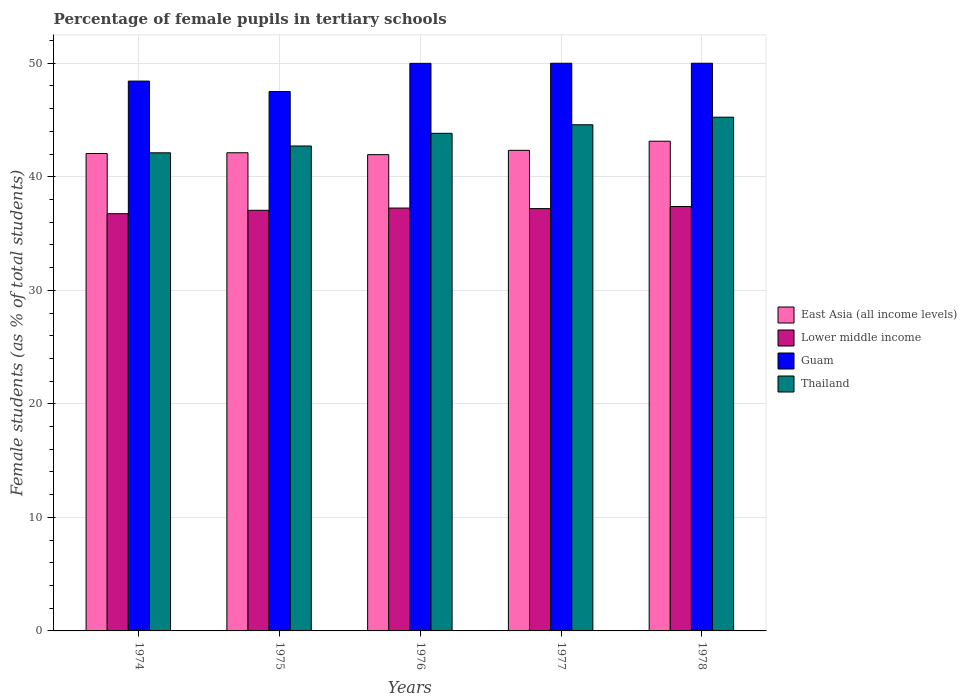How many different coloured bars are there?
Offer a terse response. 4. What is the label of the 2nd group of bars from the left?
Keep it short and to the point. 1975. What is the percentage of female pupils in tertiary schools in East Asia (all income levels) in 1978?
Provide a short and direct response. 43.13. Across all years, what is the maximum percentage of female pupils in tertiary schools in Guam?
Offer a terse response. 50. Across all years, what is the minimum percentage of female pupils in tertiary schools in Guam?
Provide a short and direct response. 47.51. In which year was the percentage of female pupils in tertiary schools in East Asia (all income levels) maximum?
Your response must be concise. 1978. In which year was the percentage of female pupils in tertiary schools in Guam minimum?
Make the answer very short. 1975. What is the total percentage of female pupils in tertiary schools in Thailand in the graph?
Offer a terse response. 218.49. What is the difference between the percentage of female pupils in tertiary schools in Thailand in 1974 and that in 1978?
Give a very brief answer. -3.14. What is the difference between the percentage of female pupils in tertiary schools in Lower middle income in 1976 and the percentage of female pupils in tertiary schools in East Asia (all income levels) in 1978?
Offer a terse response. -5.89. What is the average percentage of female pupils in tertiary schools in Lower middle income per year?
Offer a terse response. 37.13. In the year 1974, what is the difference between the percentage of female pupils in tertiary schools in Guam and percentage of female pupils in tertiary schools in Thailand?
Give a very brief answer. 6.32. What is the ratio of the percentage of female pupils in tertiary schools in East Asia (all income levels) in 1974 to that in 1978?
Keep it short and to the point. 0.97. Is the difference between the percentage of female pupils in tertiary schools in Guam in 1975 and 1978 greater than the difference between the percentage of female pupils in tertiary schools in Thailand in 1975 and 1978?
Offer a terse response. Yes. What is the difference between the highest and the second highest percentage of female pupils in tertiary schools in Lower middle income?
Make the answer very short. 0.14. What is the difference between the highest and the lowest percentage of female pupils in tertiary schools in Guam?
Give a very brief answer. 2.49. In how many years, is the percentage of female pupils in tertiary schools in Guam greater than the average percentage of female pupils in tertiary schools in Guam taken over all years?
Provide a succinct answer. 3. What does the 3rd bar from the left in 1974 represents?
Offer a very short reply. Guam. What does the 3rd bar from the right in 1978 represents?
Provide a succinct answer. Lower middle income. How many bars are there?
Offer a terse response. 20. Are all the bars in the graph horizontal?
Keep it short and to the point. No. How many years are there in the graph?
Offer a very short reply. 5. What is the difference between two consecutive major ticks on the Y-axis?
Offer a very short reply. 10. Are the values on the major ticks of Y-axis written in scientific E-notation?
Keep it short and to the point. No. Does the graph contain any zero values?
Offer a very short reply. No. Does the graph contain grids?
Keep it short and to the point. Yes. Where does the legend appear in the graph?
Your answer should be very brief. Center right. How many legend labels are there?
Your response must be concise. 4. How are the legend labels stacked?
Ensure brevity in your answer.  Vertical. What is the title of the graph?
Ensure brevity in your answer.  Percentage of female pupils in tertiary schools. Does "Croatia" appear as one of the legend labels in the graph?
Make the answer very short. No. What is the label or title of the Y-axis?
Provide a short and direct response. Female students (as % of total students). What is the Female students (as % of total students) in East Asia (all income levels) in 1974?
Your answer should be very brief. 42.05. What is the Female students (as % of total students) in Lower middle income in 1974?
Provide a short and direct response. 36.75. What is the Female students (as % of total students) of Guam in 1974?
Offer a very short reply. 48.43. What is the Female students (as % of total students) in Thailand in 1974?
Offer a terse response. 42.11. What is the Female students (as % of total students) of East Asia (all income levels) in 1975?
Your answer should be compact. 42.12. What is the Female students (as % of total students) of Lower middle income in 1975?
Your response must be concise. 37.05. What is the Female students (as % of total students) of Guam in 1975?
Keep it short and to the point. 47.51. What is the Female students (as % of total students) of Thailand in 1975?
Offer a very short reply. 42.71. What is the Female students (as % of total students) in East Asia (all income levels) in 1976?
Your answer should be very brief. 41.95. What is the Female students (as % of total students) of Lower middle income in 1976?
Your answer should be compact. 37.25. What is the Female students (as % of total students) of Guam in 1976?
Ensure brevity in your answer.  49.99. What is the Female students (as % of total students) in Thailand in 1976?
Give a very brief answer. 43.83. What is the Female students (as % of total students) of East Asia (all income levels) in 1977?
Keep it short and to the point. 42.33. What is the Female students (as % of total students) of Lower middle income in 1977?
Give a very brief answer. 37.2. What is the Female students (as % of total students) in Guam in 1977?
Your response must be concise. 50. What is the Female students (as % of total students) in Thailand in 1977?
Give a very brief answer. 44.58. What is the Female students (as % of total students) in East Asia (all income levels) in 1978?
Provide a succinct answer. 43.13. What is the Female students (as % of total students) of Lower middle income in 1978?
Provide a succinct answer. 37.38. What is the Female students (as % of total students) of Guam in 1978?
Give a very brief answer. 50. What is the Female students (as % of total students) in Thailand in 1978?
Provide a short and direct response. 45.25. Across all years, what is the maximum Female students (as % of total students) in East Asia (all income levels)?
Keep it short and to the point. 43.13. Across all years, what is the maximum Female students (as % of total students) of Lower middle income?
Ensure brevity in your answer.  37.38. Across all years, what is the maximum Female students (as % of total students) of Thailand?
Ensure brevity in your answer.  45.25. Across all years, what is the minimum Female students (as % of total students) in East Asia (all income levels)?
Provide a short and direct response. 41.95. Across all years, what is the minimum Female students (as % of total students) of Lower middle income?
Offer a very short reply. 36.75. Across all years, what is the minimum Female students (as % of total students) of Guam?
Provide a short and direct response. 47.51. Across all years, what is the minimum Female students (as % of total students) in Thailand?
Provide a short and direct response. 42.11. What is the total Female students (as % of total students) of East Asia (all income levels) in the graph?
Keep it short and to the point. 211.58. What is the total Female students (as % of total students) of Lower middle income in the graph?
Make the answer very short. 185.63. What is the total Female students (as % of total students) in Guam in the graph?
Provide a succinct answer. 245.93. What is the total Female students (as % of total students) of Thailand in the graph?
Offer a terse response. 218.49. What is the difference between the Female students (as % of total students) in East Asia (all income levels) in 1974 and that in 1975?
Your response must be concise. -0.07. What is the difference between the Female students (as % of total students) in Lower middle income in 1974 and that in 1975?
Provide a succinct answer. -0.3. What is the difference between the Female students (as % of total students) in Guam in 1974 and that in 1975?
Keep it short and to the point. 0.92. What is the difference between the Female students (as % of total students) of Thailand in 1974 and that in 1975?
Make the answer very short. -0.6. What is the difference between the Female students (as % of total students) in East Asia (all income levels) in 1974 and that in 1976?
Offer a very short reply. 0.1. What is the difference between the Female students (as % of total students) in Lower middle income in 1974 and that in 1976?
Give a very brief answer. -0.5. What is the difference between the Female students (as % of total students) in Guam in 1974 and that in 1976?
Your answer should be compact. -1.56. What is the difference between the Female students (as % of total students) in Thailand in 1974 and that in 1976?
Offer a terse response. -1.72. What is the difference between the Female students (as % of total students) in East Asia (all income levels) in 1974 and that in 1977?
Your response must be concise. -0.28. What is the difference between the Female students (as % of total students) of Lower middle income in 1974 and that in 1977?
Provide a short and direct response. -0.45. What is the difference between the Female students (as % of total students) of Guam in 1974 and that in 1977?
Keep it short and to the point. -1.57. What is the difference between the Female students (as % of total students) in Thailand in 1974 and that in 1977?
Give a very brief answer. -2.47. What is the difference between the Female students (as % of total students) of East Asia (all income levels) in 1974 and that in 1978?
Make the answer very short. -1.08. What is the difference between the Female students (as % of total students) in Lower middle income in 1974 and that in 1978?
Your answer should be compact. -0.63. What is the difference between the Female students (as % of total students) in Guam in 1974 and that in 1978?
Your answer should be compact. -1.57. What is the difference between the Female students (as % of total students) of Thailand in 1974 and that in 1978?
Ensure brevity in your answer.  -3.14. What is the difference between the Female students (as % of total students) in East Asia (all income levels) in 1975 and that in 1976?
Ensure brevity in your answer.  0.17. What is the difference between the Female students (as % of total students) of Lower middle income in 1975 and that in 1976?
Your response must be concise. -0.2. What is the difference between the Female students (as % of total students) in Guam in 1975 and that in 1976?
Ensure brevity in your answer.  -2.48. What is the difference between the Female students (as % of total students) in Thailand in 1975 and that in 1976?
Offer a terse response. -1.12. What is the difference between the Female students (as % of total students) of East Asia (all income levels) in 1975 and that in 1977?
Ensure brevity in your answer.  -0.21. What is the difference between the Female students (as % of total students) in Lower middle income in 1975 and that in 1977?
Your response must be concise. -0.15. What is the difference between the Female students (as % of total students) of Guam in 1975 and that in 1977?
Make the answer very short. -2.49. What is the difference between the Female students (as % of total students) in Thailand in 1975 and that in 1977?
Your answer should be very brief. -1.87. What is the difference between the Female students (as % of total students) in East Asia (all income levels) in 1975 and that in 1978?
Your answer should be very brief. -1.02. What is the difference between the Female students (as % of total students) in Lower middle income in 1975 and that in 1978?
Provide a short and direct response. -0.33. What is the difference between the Female students (as % of total students) in Guam in 1975 and that in 1978?
Provide a succinct answer. -2.49. What is the difference between the Female students (as % of total students) in Thailand in 1975 and that in 1978?
Your response must be concise. -2.54. What is the difference between the Female students (as % of total students) in East Asia (all income levels) in 1976 and that in 1977?
Give a very brief answer. -0.38. What is the difference between the Female students (as % of total students) of Lower middle income in 1976 and that in 1977?
Your answer should be very brief. 0.05. What is the difference between the Female students (as % of total students) in Guam in 1976 and that in 1977?
Offer a very short reply. -0.01. What is the difference between the Female students (as % of total students) in Thailand in 1976 and that in 1977?
Make the answer very short. -0.75. What is the difference between the Female students (as % of total students) of East Asia (all income levels) in 1976 and that in 1978?
Your answer should be compact. -1.18. What is the difference between the Female students (as % of total students) in Lower middle income in 1976 and that in 1978?
Provide a succinct answer. -0.14. What is the difference between the Female students (as % of total students) in Guam in 1976 and that in 1978?
Your answer should be very brief. -0.01. What is the difference between the Female students (as % of total students) of Thailand in 1976 and that in 1978?
Keep it short and to the point. -1.42. What is the difference between the Female students (as % of total students) of East Asia (all income levels) in 1977 and that in 1978?
Your answer should be compact. -0.8. What is the difference between the Female students (as % of total students) of Lower middle income in 1977 and that in 1978?
Your response must be concise. -0.18. What is the difference between the Female students (as % of total students) in Guam in 1977 and that in 1978?
Ensure brevity in your answer.  0. What is the difference between the Female students (as % of total students) of Thailand in 1977 and that in 1978?
Offer a terse response. -0.67. What is the difference between the Female students (as % of total students) in East Asia (all income levels) in 1974 and the Female students (as % of total students) in Lower middle income in 1975?
Keep it short and to the point. 5. What is the difference between the Female students (as % of total students) in East Asia (all income levels) in 1974 and the Female students (as % of total students) in Guam in 1975?
Offer a terse response. -5.46. What is the difference between the Female students (as % of total students) of East Asia (all income levels) in 1974 and the Female students (as % of total students) of Thailand in 1975?
Provide a short and direct response. -0.66. What is the difference between the Female students (as % of total students) of Lower middle income in 1974 and the Female students (as % of total students) of Guam in 1975?
Provide a short and direct response. -10.76. What is the difference between the Female students (as % of total students) of Lower middle income in 1974 and the Female students (as % of total students) of Thailand in 1975?
Offer a very short reply. -5.96. What is the difference between the Female students (as % of total students) in Guam in 1974 and the Female students (as % of total students) in Thailand in 1975?
Provide a short and direct response. 5.72. What is the difference between the Female students (as % of total students) of East Asia (all income levels) in 1974 and the Female students (as % of total students) of Lower middle income in 1976?
Your answer should be compact. 4.8. What is the difference between the Female students (as % of total students) of East Asia (all income levels) in 1974 and the Female students (as % of total students) of Guam in 1976?
Provide a succinct answer. -7.94. What is the difference between the Female students (as % of total students) in East Asia (all income levels) in 1974 and the Female students (as % of total students) in Thailand in 1976?
Your response must be concise. -1.78. What is the difference between the Female students (as % of total students) of Lower middle income in 1974 and the Female students (as % of total students) of Guam in 1976?
Your answer should be compact. -13.24. What is the difference between the Female students (as % of total students) of Lower middle income in 1974 and the Female students (as % of total students) of Thailand in 1976?
Provide a succinct answer. -7.08. What is the difference between the Female students (as % of total students) of Guam in 1974 and the Female students (as % of total students) of Thailand in 1976?
Make the answer very short. 4.6. What is the difference between the Female students (as % of total students) of East Asia (all income levels) in 1974 and the Female students (as % of total students) of Lower middle income in 1977?
Your answer should be compact. 4.85. What is the difference between the Female students (as % of total students) of East Asia (all income levels) in 1974 and the Female students (as % of total students) of Guam in 1977?
Offer a very short reply. -7.95. What is the difference between the Female students (as % of total students) in East Asia (all income levels) in 1974 and the Female students (as % of total students) in Thailand in 1977?
Make the answer very short. -2.53. What is the difference between the Female students (as % of total students) of Lower middle income in 1974 and the Female students (as % of total students) of Guam in 1977?
Give a very brief answer. -13.25. What is the difference between the Female students (as % of total students) in Lower middle income in 1974 and the Female students (as % of total students) in Thailand in 1977?
Your answer should be very brief. -7.83. What is the difference between the Female students (as % of total students) of Guam in 1974 and the Female students (as % of total students) of Thailand in 1977?
Make the answer very short. 3.85. What is the difference between the Female students (as % of total students) in East Asia (all income levels) in 1974 and the Female students (as % of total students) in Lower middle income in 1978?
Your response must be concise. 4.67. What is the difference between the Female students (as % of total students) in East Asia (all income levels) in 1974 and the Female students (as % of total students) in Guam in 1978?
Your answer should be very brief. -7.95. What is the difference between the Female students (as % of total students) of East Asia (all income levels) in 1974 and the Female students (as % of total students) of Thailand in 1978?
Offer a terse response. -3.2. What is the difference between the Female students (as % of total students) in Lower middle income in 1974 and the Female students (as % of total students) in Guam in 1978?
Ensure brevity in your answer.  -13.25. What is the difference between the Female students (as % of total students) of Lower middle income in 1974 and the Female students (as % of total students) of Thailand in 1978?
Keep it short and to the point. -8.5. What is the difference between the Female students (as % of total students) in Guam in 1974 and the Female students (as % of total students) in Thailand in 1978?
Your answer should be compact. 3.18. What is the difference between the Female students (as % of total students) of East Asia (all income levels) in 1975 and the Female students (as % of total students) of Lower middle income in 1976?
Provide a succinct answer. 4.87. What is the difference between the Female students (as % of total students) in East Asia (all income levels) in 1975 and the Female students (as % of total students) in Guam in 1976?
Provide a succinct answer. -7.88. What is the difference between the Female students (as % of total students) of East Asia (all income levels) in 1975 and the Female students (as % of total students) of Thailand in 1976?
Offer a very short reply. -1.71. What is the difference between the Female students (as % of total students) of Lower middle income in 1975 and the Female students (as % of total students) of Guam in 1976?
Provide a short and direct response. -12.94. What is the difference between the Female students (as % of total students) in Lower middle income in 1975 and the Female students (as % of total students) in Thailand in 1976?
Ensure brevity in your answer.  -6.78. What is the difference between the Female students (as % of total students) of Guam in 1975 and the Female students (as % of total students) of Thailand in 1976?
Your response must be concise. 3.68. What is the difference between the Female students (as % of total students) in East Asia (all income levels) in 1975 and the Female students (as % of total students) in Lower middle income in 1977?
Provide a succinct answer. 4.92. What is the difference between the Female students (as % of total students) in East Asia (all income levels) in 1975 and the Female students (as % of total students) in Guam in 1977?
Your answer should be compact. -7.88. What is the difference between the Female students (as % of total students) in East Asia (all income levels) in 1975 and the Female students (as % of total students) in Thailand in 1977?
Provide a succinct answer. -2.47. What is the difference between the Female students (as % of total students) in Lower middle income in 1975 and the Female students (as % of total students) in Guam in 1977?
Ensure brevity in your answer.  -12.95. What is the difference between the Female students (as % of total students) in Lower middle income in 1975 and the Female students (as % of total students) in Thailand in 1977?
Make the answer very short. -7.54. What is the difference between the Female students (as % of total students) of Guam in 1975 and the Female students (as % of total students) of Thailand in 1977?
Provide a short and direct response. 2.93. What is the difference between the Female students (as % of total students) in East Asia (all income levels) in 1975 and the Female students (as % of total students) in Lower middle income in 1978?
Your response must be concise. 4.73. What is the difference between the Female students (as % of total students) of East Asia (all income levels) in 1975 and the Female students (as % of total students) of Guam in 1978?
Keep it short and to the point. -7.88. What is the difference between the Female students (as % of total students) in East Asia (all income levels) in 1975 and the Female students (as % of total students) in Thailand in 1978?
Offer a terse response. -3.13. What is the difference between the Female students (as % of total students) of Lower middle income in 1975 and the Female students (as % of total students) of Guam in 1978?
Offer a very short reply. -12.95. What is the difference between the Female students (as % of total students) of Lower middle income in 1975 and the Female students (as % of total students) of Thailand in 1978?
Make the answer very short. -8.2. What is the difference between the Female students (as % of total students) of Guam in 1975 and the Female students (as % of total students) of Thailand in 1978?
Make the answer very short. 2.26. What is the difference between the Female students (as % of total students) in East Asia (all income levels) in 1976 and the Female students (as % of total students) in Lower middle income in 1977?
Your answer should be very brief. 4.75. What is the difference between the Female students (as % of total students) in East Asia (all income levels) in 1976 and the Female students (as % of total students) in Guam in 1977?
Your answer should be very brief. -8.05. What is the difference between the Female students (as % of total students) of East Asia (all income levels) in 1976 and the Female students (as % of total students) of Thailand in 1977?
Offer a very short reply. -2.63. What is the difference between the Female students (as % of total students) of Lower middle income in 1976 and the Female students (as % of total students) of Guam in 1977?
Provide a short and direct response. -12.75. What is the difference between the Female students (as % of total students) in Lower middle income in 1976 and the Female students (as % of total students) in Thailand in 1977?
Give a very brief answer. -7.34. What is the difference between the Female students (as % of total students) in Guam in 1976 and the Female students (as % of total students) in Thailand in 1977?
Provide a succinct answer. 5.41. What is the difference between the Female students (as % of total students) of East Asia (all income levels) in 1976 and the Female students (as % of total students) of Lower middle income in 1978?
Make the answer very short. 4.57. What is the difference between the Female students (as % of total students) in East Asia (all income levels) in 1976 and the Female students (as % of total students) in Guam in 1978?
Give a very brief answer. -8.05. What is the difference between the Female students (as % of total students) in East Asia (all income levels) in 1976 and the Female students (as % of total students) in Thailand in 1978?
Your response must be concise. -3.3. What is the difference between the Female students (as % of total students) of Lower middle income in 1976 and the Female students (as % of total students) of Guam in 1978?
Your response must be concise. -12.75. What is the difference between the Female students (as % of total students) of Lower middle income in 1976 and the Female students (as % of total students) of Thailand in 1978?
Provide a succinct answer. -8. What is the difference between the Female students (as % of total students) in Guam in 1976 and the Female students (as % of total students) in Thailand in 1978?
Your answer should be compact. 4.74. What is the difference between the Female students (as % of total students) of East Asia (all income levels) in 1977 and the Female students (as % of total students) of Lower middle income in 1978?
Ensure brevity in your answer.  4.95. What is the difference between the Female students (as % of total students) in East Asia (all income levels) in 1977 and the Female students (as % of total students) in Guam in 1978?
Provide a short and direct response. -7.67. What is the difference between the Female students (as % of total students) of East Asia (all income levels) in 1977 and the Female students (as % of total students) of Thailand in 1978?
Offer a very short reply. -2.92. What is the difference between the Female students (as % of total students) in Lower middle income in 1977 and the Female students (as % of total students) in Guam in 1978?
Your response must be concise. -12.8. What is the difference between the Female students (as % of total students) in Lower middle income in 1977 and the Female students (as % of total students) in Thailand in 1978?
Keep it short and to the point. -8.05. What is the difference between the Female students (as % of total students) in Guam in 1977 and the Female students (as % of total students) in Thailand in 1978?
Ensure brevity in your answer.  4.75. What is the average Female students (as % of total students) in East Asia (all income levels) per year?
Provide a succinct answer. 42.32. What is the average Female students (as % of total students) in Lower middle income per year?
Offer a very short reply. 37.12. What is the average Female students (as % of total students) in Guam per year?
Your answer should be compact. 49.19. What is the average Female students (as % of total students) of Thailand per year?
Your answer should be compact. 43.7. In the year 1974, what is the difference between the Female students (as % of total students) of East Asia (all income levels) and Female students (as % of total students) of Lower middle income?
Give a very brief answer. 5.3. In the year 1974, what is the difference between the Female students (as % of total students) in East Asia (all income levels) and Female students (as % of total students) in Guam?
Your answer should be very brief. -6.38. In the year 1974, what is the difference between the Female students (as % of total students) of East Asia (all income levels) and Female students (as % of total students) of Thailand?
Your response must be concise. -0.06. In the year 1974, what is the difference between the Female students (as % of total students) of Lower middle income and Female students (as % of total students) of Guam?
Keep it short and to the point. -11.68. In the year 1974, what is the difference between the Female students (as % of total students) of Lower middle income and Female students (as % of total students) of Thailand?
Your answer should be compact. -5.36. In the year 1974, what is the difference between the Female students (as % of total students) in Guam and Female students (as % of total students) in Thailand?
Your answer should be very brief. 6.32. In the year 1975, what is the difference between the Female students (as % of total students) of East Asia (all income levels) and Female students (as % of total students) of Lower middle income?
Your answer should be compact. 5.07. In the year 1975, what is the difference between the Female students (as % of total students) in East Asia (all income levels) and Female students (as % of total students) in Guam?
Keep it short and to the point. -5.39. In the year 1975, what is the difference between the Female students (as % of total students) of East Asia (all income levels) and Female students (as % of total students) of Thailand?
Your answer should be very brief. -0.6. In the year 1975, what is the difference between the Female students (as % of total students) of Lower middle income and Female students (as % of total students) of Guam?
Your answer should be compact. -10.46. In the year 1975, what is the difference between the Female students (as % of total students) of Lower middle income and Female students (as % of total students) of Thailand?
Give a very brief answer. -5.67. In the year 1975, what is the difference between the Female students (as % of total students) in Guam and Female students (as % of total students) in Thailand?
Provide a succinct answer. 4.8. In the year 1976, what is the difference between the Female students (as % of total students) of East Asia (all income levels) and Female students (as % of total students) of Lower middle income?
Your answer should be compact. 4.7. In the year 1976, what is the difference between the Female students (as % of total students) in East Asia (all income levels) and Female students (as % of total students) in Guam?
Give a very brief answer. -8.04. In the year 1976, what is the difference between the Female students (as % of total students) in East Asia (all income levels) and Female students (as % of total students) in Thailand?
Provide a short and direct response. -1.88. In the year 1976, what is the difference between the Female students (as % of total students) in Lower middle income and Female students (as % of total students) in Guam?
Give a very brief answer. -12.75. In the year 1976, what is the difference between the Female students (as % of total students) in Lower middle income and Female students (as % of total students) in Thailand?
Make the answer very short. -6.58. In the year 1976, what is the difference between the Female students (as % of total students) in Guam and Female students (as % of total students) in Thailand?
Provide a succinct answer. 6.16. In the year 1977, what is the difference between the Female students (as % of total students) of East Asia (all income levels) and Female students (as % of total students) of Lower middle income?
Give a very brief answer. 5.13. In the year 1977, what is the difference between the Female students (as % of total students) of East Asia (all income levels) and Female students (as % of total students) of Guam?
Your response must be concise. -7.67. In the year 1977, what is the difference between the Female students (as % of total students) of East Asia (all income levels) and Female students (as % of total students) of Thailand?
Provide a succinct answer. -2.25. In the year 1977, what is the difference between the Female students (as % of total students) in Lower middle income and Female students (as % of total students) in Guam?
Give a very brief answer. -12.8. In the year 1977, what is the difference between the Female students (as % of total students) in Lower middle income and Female students (as % of total students) in Thailand?
Ensure brevity in your answer.  -7.38. In the year 1977, what is the difference between the Female students (as % of total students) of Guam and Female students (as % of total students) of Thailand?
Ensure brevity in your answer.  5.42. In the year 1978, what is the difference between the Female students (as % of total students) of East Asia (all income levels) and Female students (as % of total students) of Lower middle income?
Offer a terse response. 5.75. In the year 1978, what is the difference between the Female students (as % of total students) of East Asia (all income levels) and Female students (as % of total students) of Guam?
Provide a succinct answer. -6.87. In the year 1978, what is the difference between the Female students (as % of total students) in East Asia (all income levels) and Female students (as % of total students) in Thailand?
Your answer should be compact. -2.12. In the year 1978, what is the difference between the Female students (as % of total students) of Lower middle income and Female students (as % of total students) of Guam?
Offer a terse response. -12.62. In the year 1978, what is the difference between the Female students (as % of total students) in Lower middle income and Female students (as % of total students) in Thailand?
Ensure brevity in your answer.  -7.87. In the year 1978, what is the difference between the Female students (as % of total students) in Guam and Female students (as % of total students) in Thailand?
Your response must be concise. 4.75. What is the ratio of the Female students (as % of total students) of East Asia (all income levels) in 1974 to that in 1975?
Make the answer very short. 1. What is the ratio of the Female students (as % of total students) of Lower middle income in 1974 to that in 1975?
Your answer should be compact. 0.99. What is the ratio of the Female students (as % of total students) in Guam in 1974 to that in 1975?
Offer a terse response. 1.02. What is the ratio of the Female students (as % of total students) in Thailand in 1974 to that in 1975?
Offer a terse response. 0.99. What is the ratio of the Female students (as % of total students) of East Asia (all income levels) in 1974 to that in 1976?
Give a very brief answer. 1. What is the ratio of the Female students (as % of total students) of Lower middle income in 1974 to that in 1976?
Provide a short and direct response. 0.99. What is the ratio of the Female students (as % of total students) of Guam in 1974 to that in 1976?
Give a very brief answer. 0.97. What is the ratio of the Female students (as % of total students) in Thailand in 1974 to that in 1976?
Keep it short and to the point. 0.96. What is the ratio of the Female students (as % of total students) of East Asia (all income levels) in 1974 to that in 1977?
Your answer should be compact. 0.99. What is the ratio of the Female students (as % of total students) of Lower middle income in 1974 to that in 1977?
Your response must be concise. 0.99. What is the ratio of the Female students (as % of total students) of Guam in 1974 to that in 1977?
Your answer should be very brief. 0.97. What is the ratio of the Female students (as % of total students) of Thailand in 1974 to that in 1977?
Ensure brevity in your answer.  0.94. What is the ratio of the Female students (as % of total students) in East Asia (all income levels) in 1974 to that in 1978?
Provide a short and direct response. 0.97. What is the ratio of the Female students (as % of total students) in Lower middle income in 1974 to that in 1978?
Provide a short and direct response. 0.98. What is the ratio of the Female students (as % of total students) in Guam in 1974 to that in 1978?
Your answer should be compact. 0.97. What is the ratio of the Female students (as % of total students) of Thailand in 1974 to that in 1978?
Offer a terse response. 0.93. What is the ratio of the Female students (as % of total students) in East Asia (all income levels) in 1975 to that in 1976?
Keep it short and to the point. 1. What is the ratio of the Female students (as % of total students) in Guam in 1975 to that in 1976?
Offer a very short reply. 0.95. What is the ratio of the Female students (as % of total students) in Thailand in 1975 to that in 1976?
Ensure brevity in your answer.  0.97. What is the ratio of the Female students (as % of total students) of East Asia (all income levels) in 1975 to that in 1977?
Provide a succinct answer. 0.99. What is the ratio of the Female students (as % of total students) of Guam in 1975 to that in 1977?
Keep it short and to the point. 0.95. What is the ratio of the Female students (as % of total students) in Thailand in 1975 to that in 1977?
Keep it short and to the point. 0.96. What is the ratio of the Female students (as % of total students) of East Asia (all income levels) in 1975 to that in 1978?
Provide a succinct answer. 0.98. What is the ratio of the Female students (as % of total students) in Guam in 1975 to that in 1978?
Provide a succinct answer. 0.95. What is the ratio of the Female students (as % of total students) of Thailand in 1975 to that in 1978?
Ensure brevity in your answer.  0.94. What is the ratio of the Female students (as % of total students) in East Asia (all income levels) in 1976 to that in 1977?
Provide a short and direct response. 0.99. What is the ratio of the Female students (as % of total students) of Guam in 1976 to that in 1977?
Provide a short and direct response. 1. What is the ratio of the Female students (as % of total students) in Thailand in 1976 to that in 1977?
Provide a short and direct response. 0.98. What is the ratio of the Female students (as % of total students) of East Asia (all income levels) in 1976 to that in 1978?
Offer a very short reply. 0.97. What is the ratio of the Female students (as % of total students) of Guam in 1976 to that in 1978?
Give a very brief answer. 1. What is the ratio of the Female students (as % of total students) of Thailand in 1976 to that in 1978?
Ensure brevity in your answer.  0.97. What is the ratio of the Female students (as % of total students) in East Asia (all income levels) in 1977 to that in 1978?
Offer a terse response. 0.98. What is the ratio of the Female students (as % of total students) in Lower middle income in 1977 to that in 1978?
Provide a succinct answer. 1. What is the ratio of the Female students (as % of total students) in Guam in 1977 to that in 1978?
Ensure brevity in your answer.  1. What is the ratio of the Female students (as % of total students) in Thailand in 1977 to that in 1978?
Your answer should be very brief. 0.99. What is the difference between the highest and the second highest Female students (as % of total students) in East Asia (all income levels)?
Ensure brevity in your answer.  0.8. What is the difference between the highest and the second highest Female students (as % of total students) of Lower middle income?
Make the answer very short. 0.14. What is the difference between the highest and the second highest Female students (as % of total students) in Guam?
Your answer should be very brief. 0. What is the difference between the highest and the second highest Female students (as % of total students) of Thailand?
Your answer should be compact. 0.67. What is the difference between the highest and the lowest Female students (as % of total students) of East Asia (all income levels)?
Give a very brief answer. 1.18. What is the difference between the highest and the lowest Female students (as % of total students) in Lower middle income?
Your response must be concise. 0.63. What is the difference between the highest and the lowest Female students (as % of total students) in Guam?
Your response must be concise. 2.49. What is the difference between the highest and the lowest Female students (as % of total students) in Thailand?
Provide a short and direct response. 3.14. 